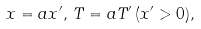<formula> <loc_0><loc_0><loc_500><loc_500>x = a x ^ { \prime } , \, T = a T ^ { \prime } \, ( x ^ { \prime } > 0 ) ,</formula> 